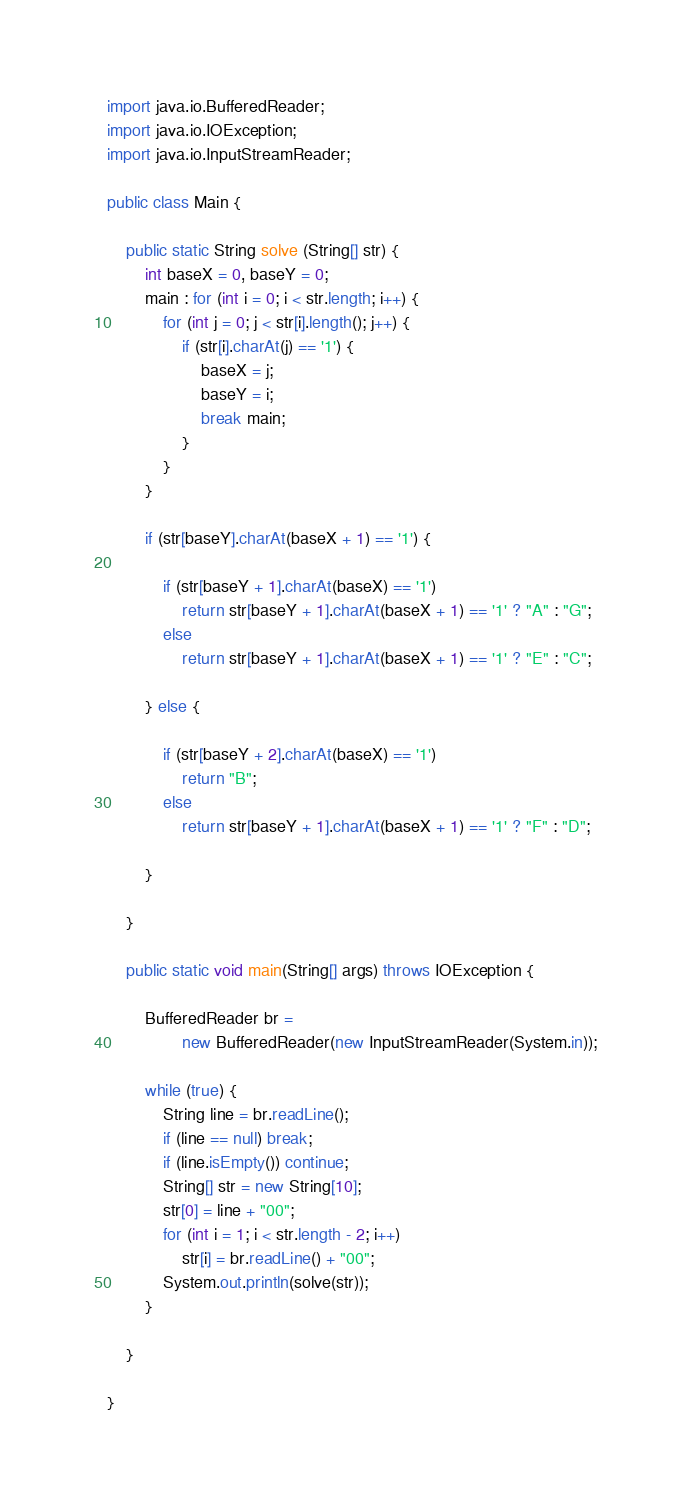Convert code to text. <code><loc_0><loc_0><loc_500><loc_500><_Java_>import java.io.BufferedReader;
import java.io.IOException;
import java.io.InputStreamReader;

public class Main {

	public static String solve (String[] str) {
		int baseX = 0, baseY = 0;
		main : for (int i = 0; i < str.length; i++) {
			for (int j = 0; j < str[i].length(); j++) {
				if (str[i].charAt(j) == '1') {
					baseX = j;
					baseY = i;
					break main;
				}
			}
		}

		if (str[baseY].charAt(baseX + 1) == '1') {

			if (str[baseY + 1].charAt(baseX) == '1')
				return str[baseY + 1].charAt(baseX + 1) == '1' ? "A" : "G";
			else
				return str[baseY + 1].charAt(baseX + 1) == '1' ? "E" : "C";

		} else {

			if (str[baseY + 2].charAt(baseX) == '1')
				return "B";
			else
				return str[baseY + 1].charAt(baseX + 1) == '1' ? "F" : "D";

		}

	}

	public static void main(String[] args) throws IOException {

		BufferedReader br =
				new BufferedReader(new InputStreamReader(System.in));

		while (true) {
			String line = br.readLine();
			if (line == null) break;
			if (line.isEmpty()) continue;
			String[] str = new String[10];
			str[0] = line + "00";
			for (int i = 1; i < str.length - 2; i++)
				str[i] = br.readLine() + "00";
			System.out.println(solve(str));
		}

	}

}</code> 